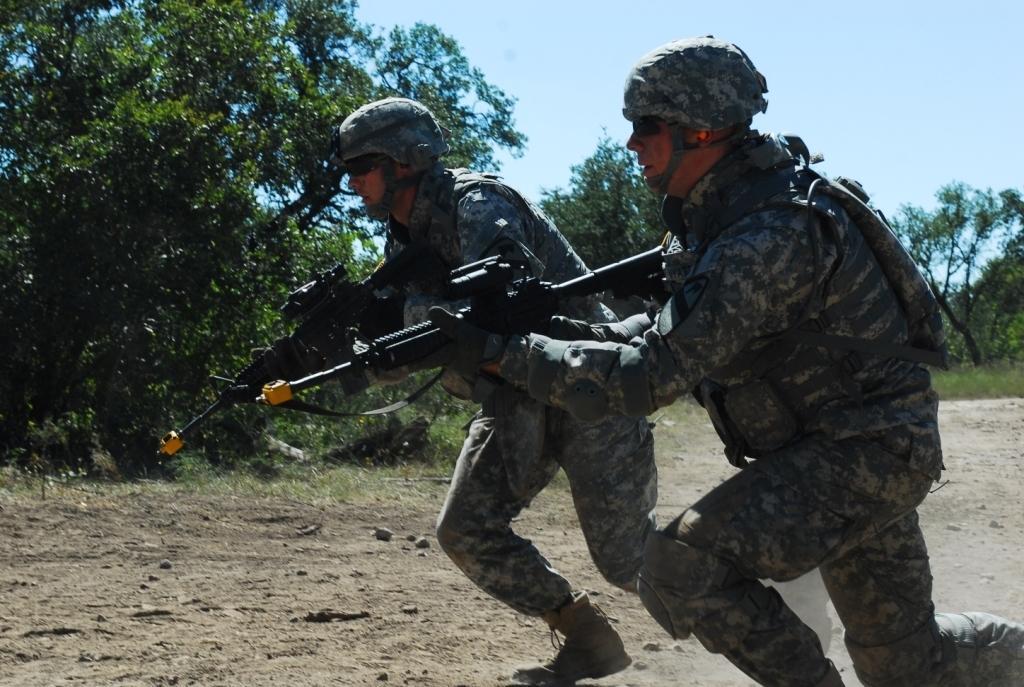In one or two sentences, can you explain what this image depicts? In this image there are two people who wore army dress and they are holding guns in there hands and they are about to run they are also wearing helmets and towards right of the second person there are also some trees 